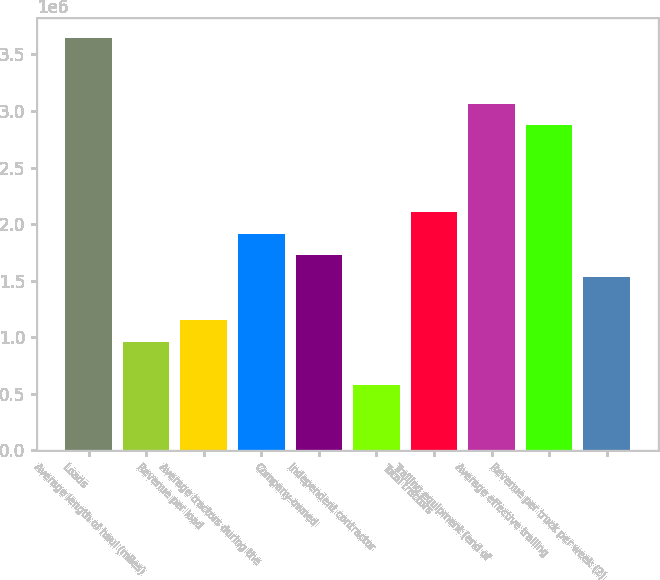Convert chart. <chart><loc_0><loc_0><loc_500><loc_500><bar_chart><fcel>Loads<fcel>Average length of haul (miles)<fcel>Revenue per load<fcel>Average tractors during the<fcel>Company-owned<fcel>Independent contractor<fcel>Total tractors<fcel>Trailing equipment (end of<fcel>Average effective trailing<fcel>Revenue per truck per week (2)<nl><fcel>3.64096e+06<fcel>958159<fcel>1.14979e+06<fcel>1.9163e+06<fcel>1.72467e+06<fcel>574901<fcel>2.10793e+06<fcel>3.06608e+06<fcel>2.87445e+06<fcel>1.53305e+06<nl></chart> 